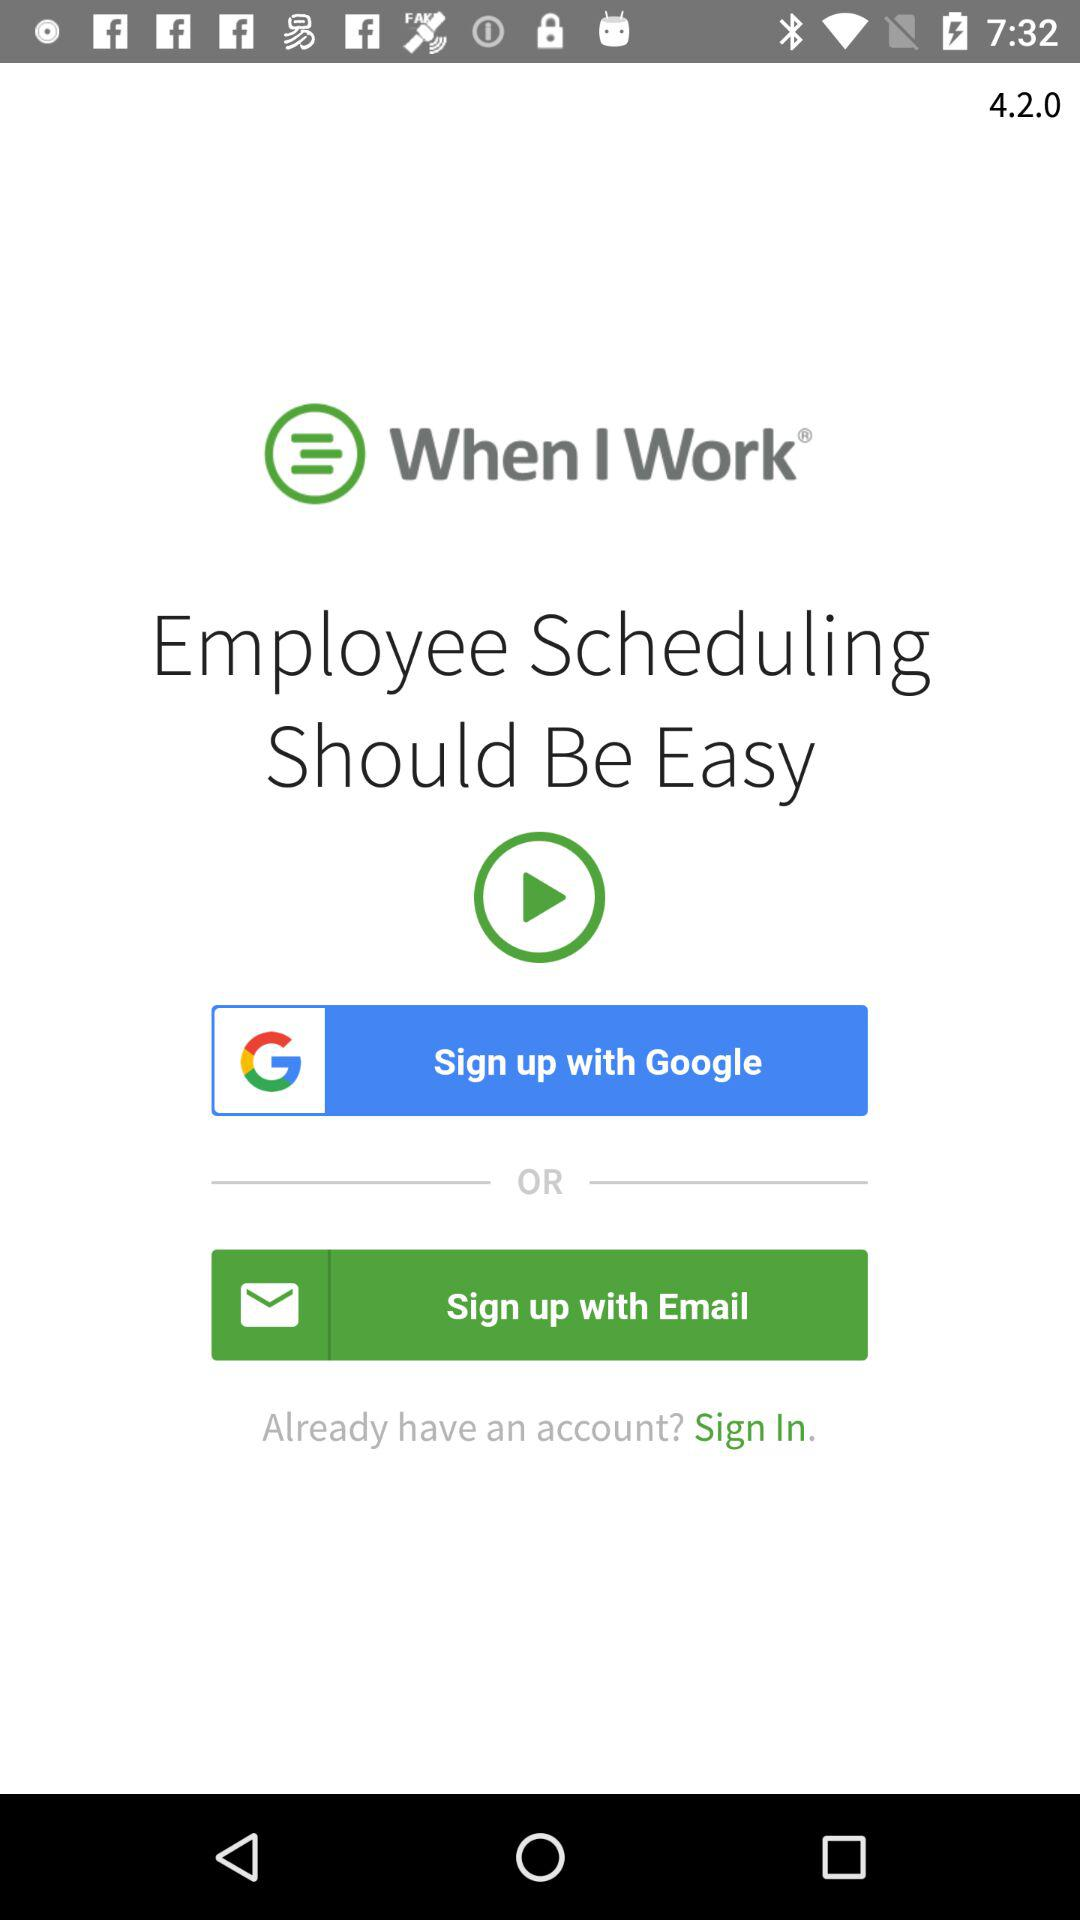What is the app name? The app name is "When I Work". 